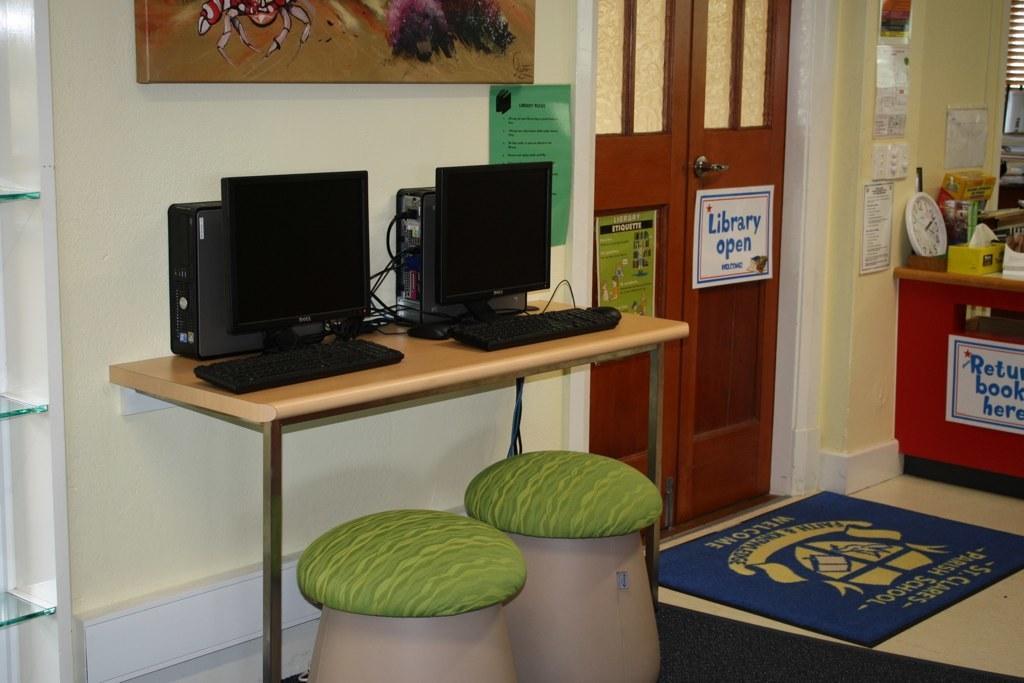How would you summarize this image in a sentence or two? In this image we can see monitors, CPUs, table, wall, door, stools, name boards and other objects. On the right side of the image there is a clock, name boards, table and other objects. At the bottom of the image there is the mat. On the left side of the image there is the wall. 